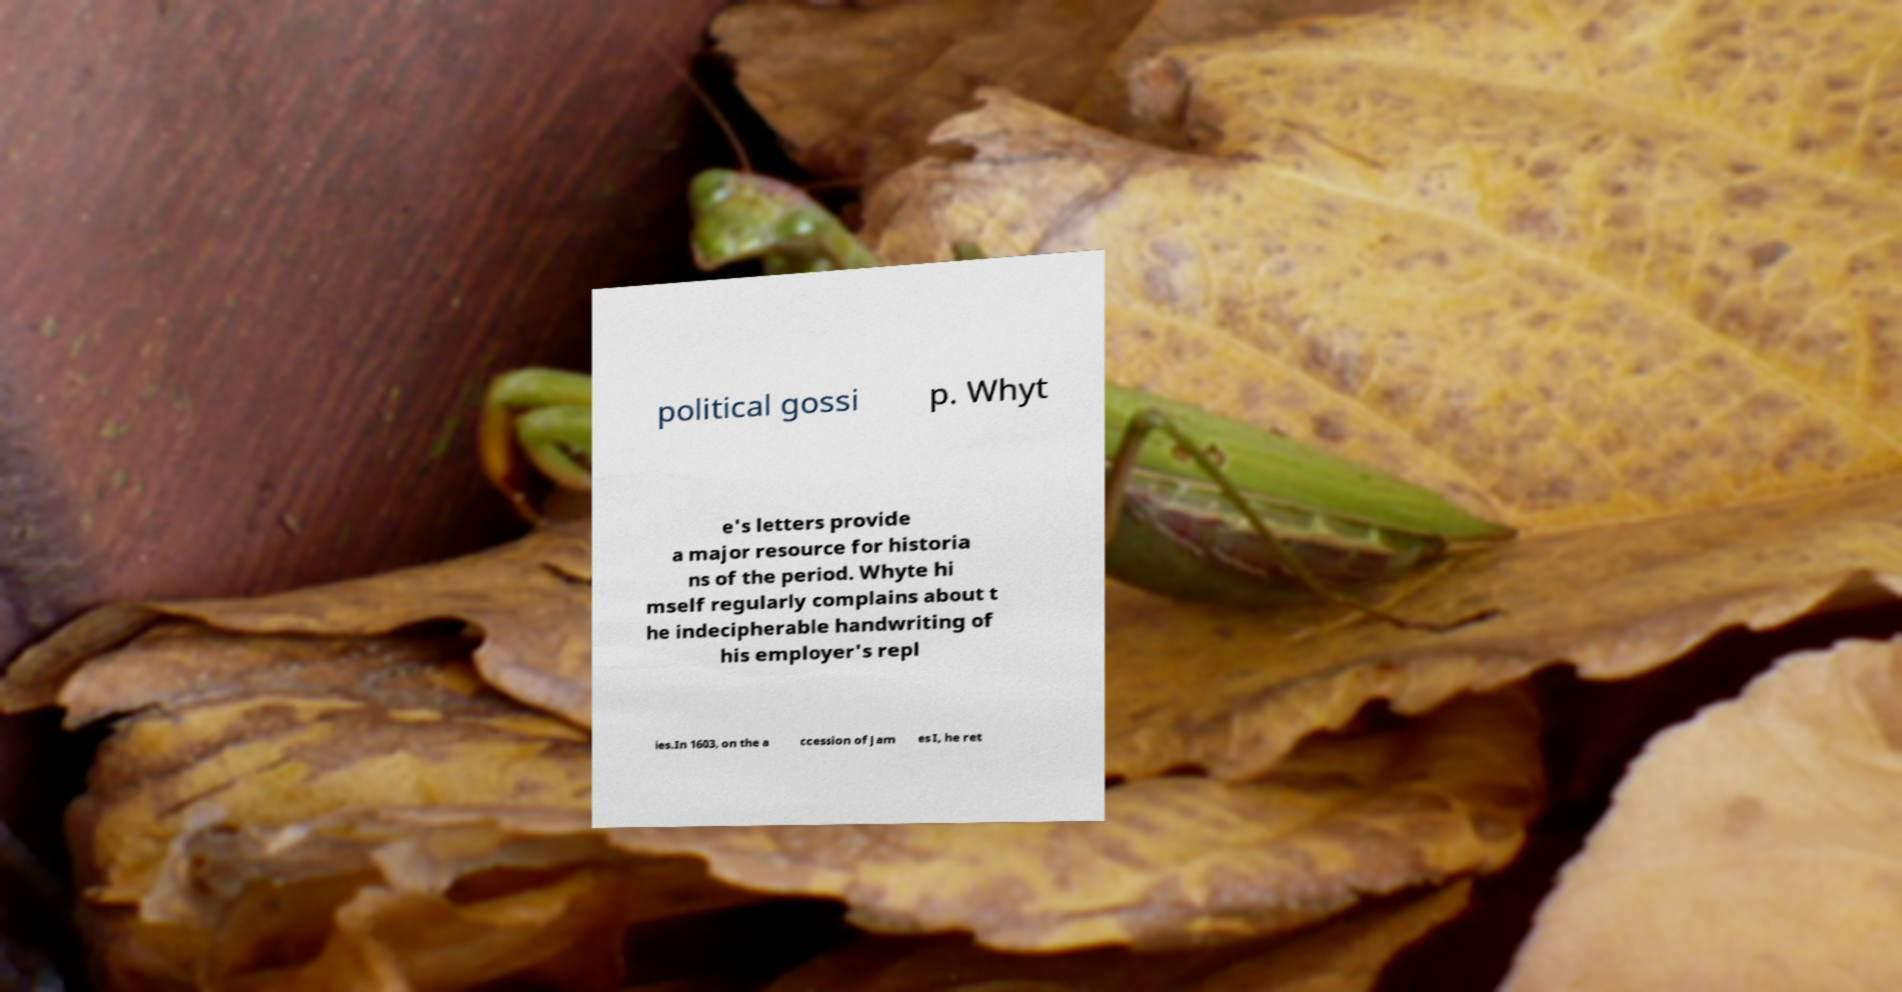Could you extract and type out the text from this image? political gossi p. Whyt e's letters provide a major resource for historia ns of the period. Whyte hi mself regularly complains about t he indecipherable handwriting of his employer's repl ies.In 1603, on the a ccession of Jam es I, he ret 